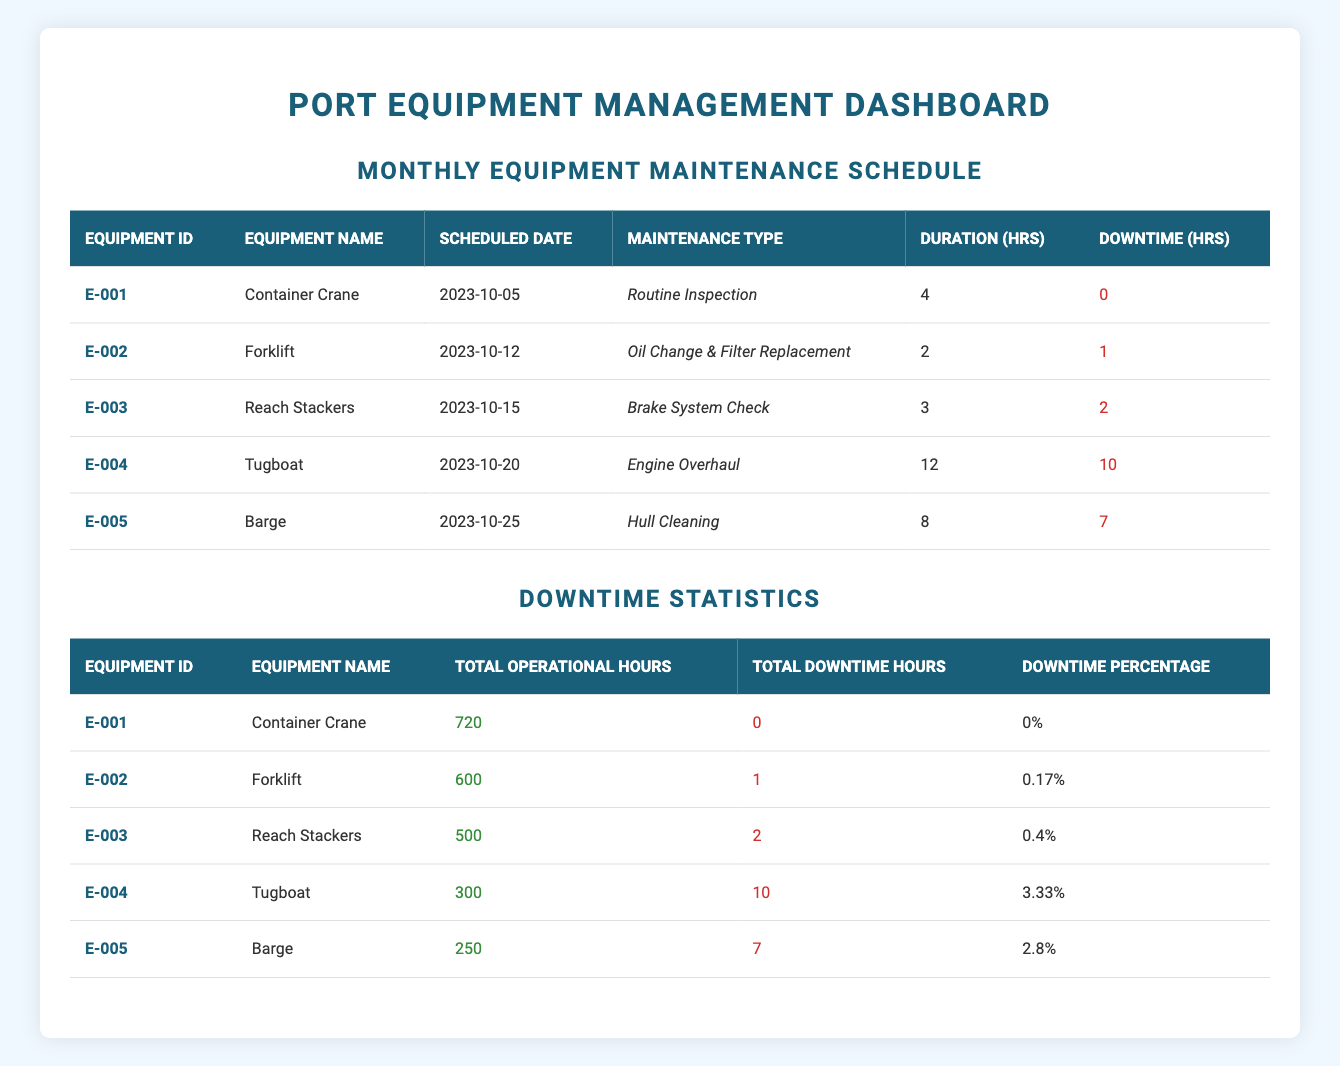What is the scheduled maintenance date for the Barge? The table indicates that the Barge's scheduled maintenance date is listed under the "Scheduled Date" column. Looking specifically for the row corresponding to the Barge, I find the date is 2023-10-25.
Answer: 2023-10-25 How many hours of downtime did the Forklift experience? From the "Downtime (hrs)" column in the Forklift's row, I see that it notes 1 hour of downtime recorded for maintenance.
Answer: 1 What is the total operational hours for the Container Crane? The table shows the total operational hours for the Container Crane in the Downtime Statistics section. Searching for the corresponding row, it states 720 hours.
Answer: 720 Which equipment had the highest downtime percentage and what was it? To determine this, I must compare the Downtime Percentage for each piece of equipment. Examining the percentages listed, I see the Tugboat has the highest downtime percentage at 3.33%.
Answer: Tugboat, 3.33% What is the average downtime (in hours) for all pieces of equipment? First, I sum the downtime hours across all pieces of equipment: 0 + 1 + 2 + 10 + 7 = 20 hours. There are 5 pieces of equipment, so I calculate the average as 20 hours divided by 5, which equals 4 hours.
Answer: 4 Is the Total Downtime Hours for the Reach Stackers more than the average downtime calculated from all equipment? The downtime for the Reach Stackers is noted as 2 hours. Earlier, I calculated the average downtime as 4 hours. Since 2 is less than 4, the statement is false.
Answer: No Which maintenance type required the most duration in hours? Reviewing the "Duration (hrs)" column for maintenance types, I find that the Tugboat's Engine Overhaul requires 12 hours, which is the highest duration mentioned in the table.
Answer: Engine Overhaul, 12 How many pieces of equipment had a downtime of zero hours? By inspecting the "Downtime (hrs)" column, I find that only the Container Crane has 0 downtime hours, which indicates that there is only 1 piece of equipment meeting this criteria.
Answer: 1 What is the relationship between total operational hours and total downtime hours for the Barge? The Barge has 250 total operational hours and incurred 7 total downtime hours. This indicates that the relationship suggests the Barge had downtime, which represents a significant portion of its operational time but does not exclude its functionality. It performed maintenance despite relatively low operational time.
Answer: Significant downtime in relation to operational hours 